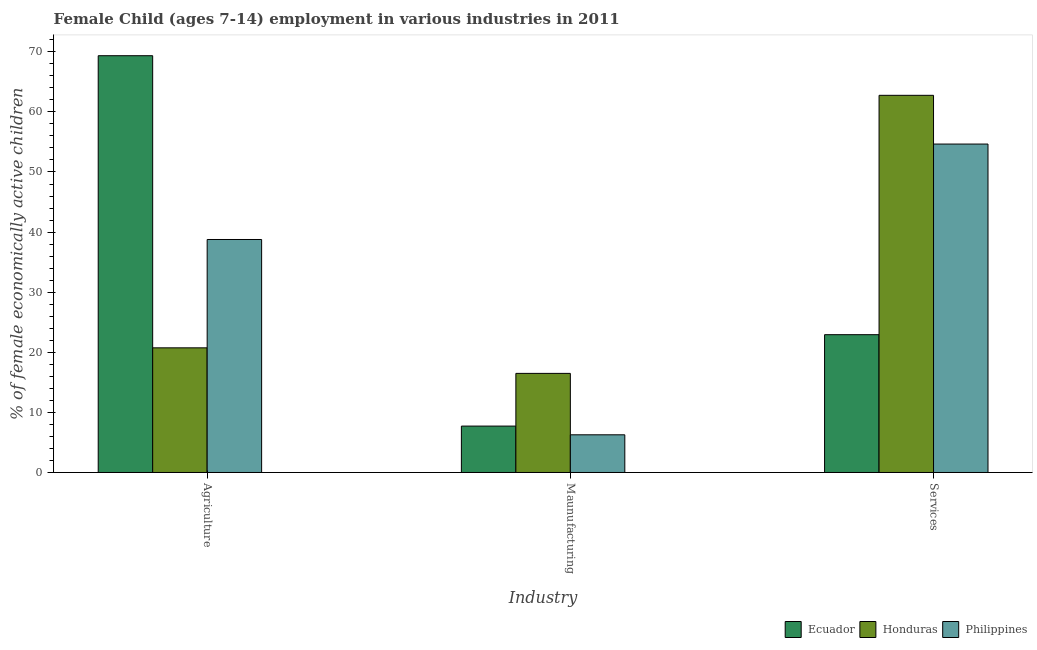How many different coloured bars are there?
Offer a very short reply. 3. Are the number of bars on each tick of the X-axis equal?
Your response must be concise. Yes. How many bars are there on the 2nd tick from the right?
Offer a terse response. 3. What is the label of the 1st group of bars from the left?
Make the answer very short. Agriculture. What is the percentage of economically active children in manufacturing in Honduras?
Give a very brief answer. 16.49. Across all countries, what is the maximum percentage of economically active children in agriculture?
Make the answer very short. 69.35. Across all countries, what is the minimum percentage of economically active children in services?
Offer a terse response. 22.93. In which country was the percentage of economically active children in agriculture maximum?
Your response must be concise. Ecuador. In which country was the percentage of economically active children in manufacturing minimum?
Ensure brevity in your answer.  Philippines. What is the total percentage of economically active children in agriculture in the graph?
Give a very brief answer. 128.86. What is the difference between the percentage of economically active children in services in Philippines and that in Ecuador?
Make the answer very short. 31.72. What is the difference between the percentage of economically active children in services in Honduras and the percentage of economically active children in manufacturing in Ecuador?
Give a very brief answer. 55.04. What is the average percentage of economically active children in manufacturing per country?
Your response must be concise. 10.16. What is the difference between the percentage of economically active children in services and percentage of economically active children in agriculture in Honduras?
Make the answer very short. 42.02. What is the ratio of the percentage of economically active children in services in Ecuador to that in Honduras?
Provide a succinct answer. 0.37. What is the difference between the highest and the second highest percentage of economically active children in agriculture?
Offer a very short reply. 30.58. What is the difference between the highest and the lowest percentage of economically active children in manufacturing?
Your answer should be compact. 10.22. Is the sum of the percentage of economically active children in services in Ecuador and Honduras greater than the maximum percentage of economically active children in agriculture across all countries?
Provide a succinct answer. Yes. What does the 3rd bar from the left in Services represents?
Offer a very short reply. Philippines. What does the 3rd bar from the right in Services represents?
Your response must be concise. Ecuador. Is it the case that in every country, the sum of the percentage of economically active children in agriculture and percentage of economically active children in manufacturing is greater than the percentage of economically active children in services?
Your answer should be very brief. No. What is the difference between two consecutive major ticks on the Y-axis?
Your response must be concise. 10. Are the values on the major ticks of Y-axis written in scientific E-notation?
Your answer should be very brief. No. Does the graph contain any zero values?
Ensure brevity in your answer.  No. Does the graph contain grids?
Ensure brevity in your answer.  No. What is the title of the graph?
Provide a short and direct response. Female Child (ages 7-14) employment in various industries in 2011. Does "Europe(all income levels)" appear as one of the legend labels in the graph?
Offer a terse response. No. What is the label or title of the X-axis?
Ensure brevity in your answer.  Industry. What is the label or title of the Y-axis?
Provide a short and direct response. % of female economically active children. What is the % of female economically active children in Ecuador in Agriculture?
Give a very brief answer. 69.35. What is the % of female economically active children of Honduras in Agriculture?
Your answer should be compact. 20.74. What is the % of female economically active children of Philippines in Agriculture?
Give a very brief answer. 38.77. What is the % of female economically active children in Ecuador in Maunufacturing?
Your answer should be compact. 7.72. What is the % of female economically active children of Honduras in Maunufacturing?
Provide a succinct answer. 16.49. What is the % of female economically active children of Philippines in Maunufacturing?
Your answer should be compact. 6.27. What is the % of female economically active children in Ecuador in Services?
Keep it short and to the point. 22.93. What is the % of female economically active children of Honduras in Services?
Offer a terse response. 62.76. What is the % of female economically active children of Philippines in Services?
Provide a short and direct response. 54.65. Across all Industry, what is the maximum % of female economically active children of Ecuador?
Provide a short and direct response. 69.35. Across all Industry, what is the maximum % of female economically active children of Honduras?
Give a very brief answer. 62.76. Across all Industry, what is the maximum % of female economically active children of Philippines?
Provide a short and direct response. 54.65. Across all Industry, what is the minimum % of female economically active children in Ecuador?
Make the answer very short. 7.72. Across all Industry, what is the minimum % of female economically active children in Honduras?
Keep it short and to the point. 16.49. Across all Industry, what is the minimum % of female economically active children of Philippines?
Offer a terse response. 6.27. What is the total % of female economically active children of Ecuador in the graph?
Keep it short and to the point. 100. What is the total % of female economically active children in Honduras in the graph?
Ensure brevity in your answer.  99.99. What is the total % of female economically active children in Philippines in the graph?
Your answer should be compact. 99.69. What is the difference between the % of female economically active children of Ecuador in Agriculture and that in Maunufacturing?
Your answer should be very brief. 61.63. What is the difference between the % of female economically active children of Honduras in Agriculture and that in Maunufacturing?
Your answer should be compact. 4.25. What is the difference between the % of female economically active children in Philippines in Agriculture and that in Maunufacturing?
Your response must be concise. 32.5. What is the difference between the % of female economically active children in Ecuador in Agriculture and that in Services?
Provide a succinct answer. 46.42. What is the difference between the % of female economically active children in Honduras in Agriculture and that in Services?
Provide a succinct answer. -42.02. What is the difference between the % of female economically active children of Philippines in Agriculture and that in Services?
Ensure brevity in your answer.  -15.88. What is the difference between the % of female economically active children of Ecuador in Maunufacturing and that in Services?
Your answer should be very brief. -15.21. What is the difference between the % of female economically active children in Honduras in Maunufacturing and that in Services?
Make the answer very short. -46.27. What is the difference between the % of female economically active children in Philippines in Maunufacturing and that in Services?
Ensure brevity in your answer.  -48.38. What is the difference between the % of female economically active children of Ecuador in Agriculture and the % of female economically active children of Honduras in Maunufacturing?
Provide a succinct answer. 52.86. What is the difference between the % of female economically active children of Ecuador in Agriculture and the % of female economically active children of Philippines in Maunufacturing?
Your answer should be very brief. 63.08. What is the difference between the % of female economically active children in Honduras in Agriculture and the % of female economically active children in Philippines in Maunufacturing?
Ensure brevity in your answer.  14.47. What is the difference between the % of female economically active children in Ecuador in Agriculture and the % of female economically active children in Honduras in Services?
Ensure brevity in your answer.  6.59. What is the difference between the % of female economically active children in Ecuador in Agriculture and the % of female economically active children in Philippines in Services?
Offer a terse response. 14.7. What is the difference between the % of female economically active children of Honduras in Agriculture and the % of female economically active children of Philippines in Services?
Provide a short and direct response. -33.91. What is the difference between the % of female economically active children in Ecuador in Maunufacturing and the % of female economically active children in Honduras in Services?
Make the answer very short. -55.04. What is the difference between the % of female economically active children in Ecuador in Maunufacturing and the % of female economically active children in Philippines in Services?
Your response must be concise. -46.93. What is the difference between the % of female economically active children of Honduras in Maunufacturing and the % of female economically active children of Philippines in Services?
Provide a short and direct response. -38.16. What is the average % of female economically active children of Ecuador per Industry?
Ensure brevity in your answer.  33.33. What is the average % of female economically active children in Honduras per Industry?
Offer a very short reply. 33.33. What is the average % of female economically active children of Philippines per Industry?
Provide a succinct answer. 33.23. What is the difference between the % of female economically active children of Ecuador and % of female economically active children of Honduras in Agriculture?
Keep it short and to the point. 48.61. What is the difference between the % of female economically active children of Ecuador and % of female economically active children of Philippines in Agriculture?
Provide a short and direct response. 30.58. What is the difference between the % of female economically active children of Honduras and % of female economically active children of Philippines in Agriculture?
Your answer should be very brief. -18.03. What is the difference between the % of female economically active children of Ecuador and % of female economically active children of Honduras in Maunufacturing?
Give a very brief answer. -8.77. What is the difference between the % of female economically active children in Ecuador and % of female economically active children in Philippines in Maunufacturing?
Give a very brief answer. 1.45. What is the difference between the % of female economically active children in Honduras and % of female economically active children in Philippines in Maunufacturing?
Make the answer very short. 10.22. What is the difference between the % of female economically active children of Ecuador and % of female economically active children of Honduras in Services?
Ensure brevity in your answer.  -39.83. What is the difference between the % of female economically active children of Ecuador and % of female economically active children of Philippines in Services?
Make the answer very short. -31.72. What is the difference between the % of female economically active children of Honduras and % of female economically active children of Philippines in Services?
Keep it short and to the point. 8.11. What is the ratio of the % of female economically active children of Ecuador in Agriculture to that in Maunufacturing?
Your answer should be compact. 8.98. What is the ratio of the % of female economically active children of Honduras in Agriculture to that in Maunufacturing?
Offer a terse response. 1.26. What is the ratio of the % of female economically active children of Philippines in Agriculture to that in Maunufacturing?
Your answer should be very brief. 6.18. What is the ratio of the % of female economically active children of Ecuador in Agriculture to that in Services?
Offer a terse response. 3.02. What is the ratio of the % of female economically active children of Honduras in Agriculture to that in Services?
Your answer should be very brief. 0.33. What is the ratio of the % of female economically active children of Philippines in Agriculture to that in Services?
Make the answer very short. 0.71. What is the ratio of the % of female economically active children of Ecuador in Maunufacturing to that in Services?
Offer a terse response. 0.34. What is the ratio of the % of female economically active children of Honduras in Maunufacturing to that in Services?
Offer a very short reply. 0.26. What is the ratio of the % of female economically active children of Philippines in Maunufacturing to that in Services?
Provide a succinct answer. 0.11. What is the difference between the highest and the second highest % of female economically active children of Ecuador?
Your answer should be compact. 46.42. What is the difference between the highest and the second highest % of female economically active children in Honduras?
Give a very brief answer. 42.02. What is the difference between the highest and the second highest % of female economically active children in Philippines?
Provide a short and direct response. 15.88. What is the difference between the highest and the lowest % of female economically active children in Ecuador?
Provide a succinct answer. 61.63. What is the difference between the highest and the lowest % of female economically active children of Honduras?
Ensure brevity in your answer.  46.27. What is the difference between the highest and the lowest % of female economically active children of Philippines?
Offer a very short reply. 48.38. 